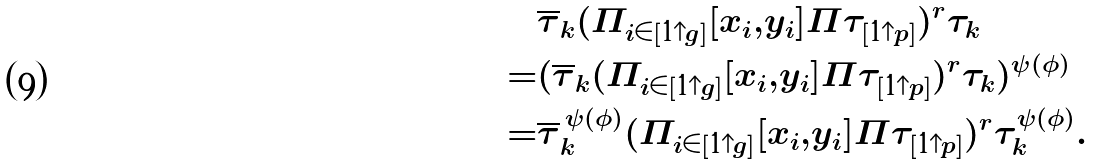<formula> <loc_0><loc_0><loc_500><loc_500>& \overline { \tau } _ { k } ( \Pi _ { i \in [ 1 { \uparrow } g ] } [ x _ { i } , y _ { i } ] \Pi \tau _ { [ 1 { \uparrow } p ] } ) ^ { r } \tau _ { k } \\ = & ( \overline { \tau } _ { k } ( \Pi _ { i \in [ 1 { \uparrow } g ] } [ x _ { i } , y _ { i } ] \Pi \tau _ { [ 1 { \uparrow } p ] } ) ^ { r } \tau _ { k } ) ^ { \psi ( \phi ) } \\ = & \overline { \tau } _ { k } ^ { \, \psi ( \phi ) } ( \Pi _ { i \in [ 1 { \uparrow } g ] } [ x _ { i } , y _ { i } ] \Pi \tau _ { [ 1 { \uparrow } p ] } ) ^ { r } \tau _ { k } ^ { \psi ( \phi ) } .</formula> 